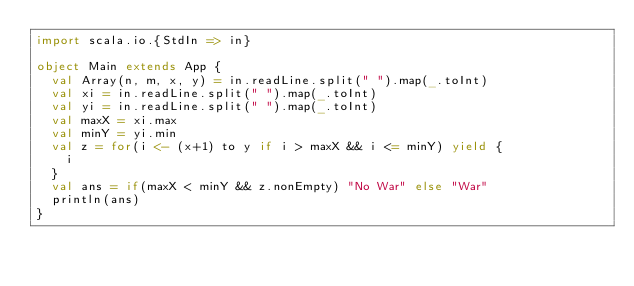Convert code to text. <code><loc_0><loc_0><loc_500><loc_500><_Scala_>import scala.io.{StdIn => in}

object Main extends App {
  val Array(n, m, x, y) = in.readLine.split(" ").map(_.toInt)
  val xi = in.readLine.split(" ").map(_.toInt)
  val yi = in.readLine.split(" ").map(_.toInt)
  val maxX = xi.max
  val minY = yi.min
  val z = for(i <- (x+1) to y if i > maxX && i <= minY) yield {
    i
  }
  val ans = if(maxX < minY && z.nonEmpty) "No War" else "War"
  println(ans)
}</code> 